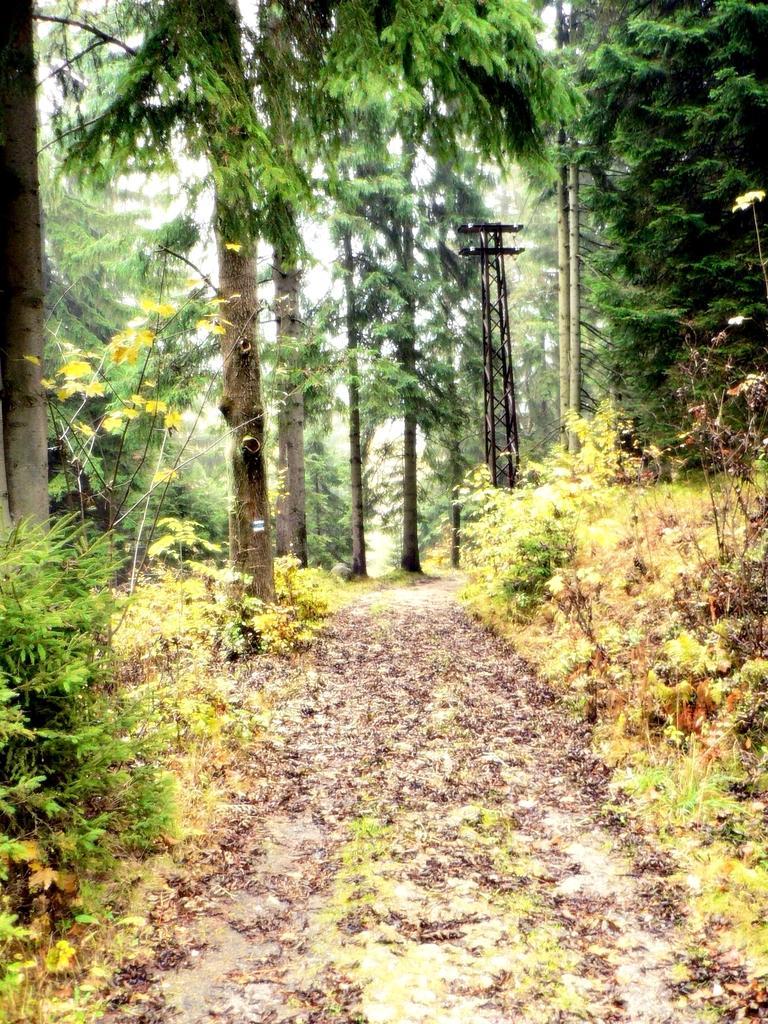In one or two sentences, can you explain what this image depicts? In this picture there is way in the center of the image and there are trees and poles in the image. 